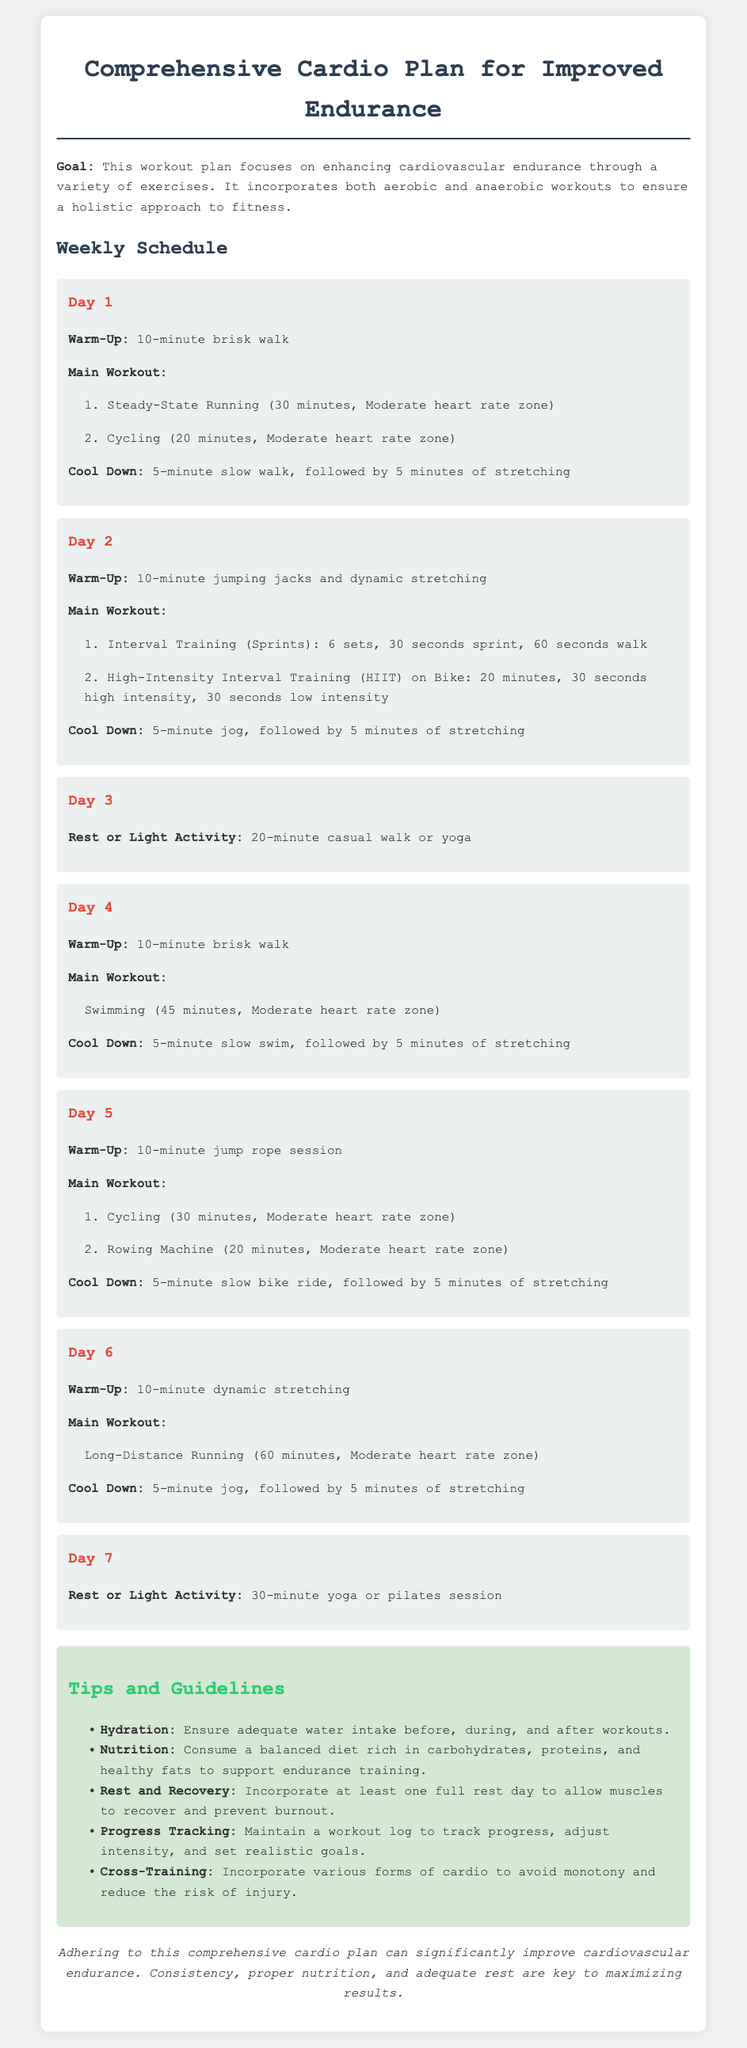What is the goal of the workout plan? The document states that the goal is to enhance cardiovascular endurance through a variety of exercises.
Answer: Enhance cardiovascular endurance How many minutes does the steady-state running last? The document specifies that steady-state running lasts for 30 minutes on Day 1.
Answer: 30 minutes What is the recommended warm-up for Day 2? The warm-up for Day 2 includes 10-minute jumping jacks and dynamic stretching.
Answer: 10-minute jumping jacks and dynamic stretching How many sets are included in the interval training on Day 2? The document indicates that there are 6 sets in the interval training on Day 2.
Answer: 6 sets What type of workout is suggested on Day 3? The document suggests a rest or light activity on Day 3, specifically a casual walk or yoga.
Answer: Rest or Light Activity What should be tracked according to the tips? The tips recommend maintaining a workout log to track progress.
Answer: Workout log How long is the long-distance running session on Day 6? The long-distance running session on Day 6 is 60 minutes long.
Answer: 60 minutes What is one of the guidelines mentioned for hydration? The document advises ensuring adequate water intake before, during, and after workouts.
Answer: Adequate water intake On which day is swimming included in the main workout? Swimming is included in the main workout on Day 4.
Answer: Day 4 